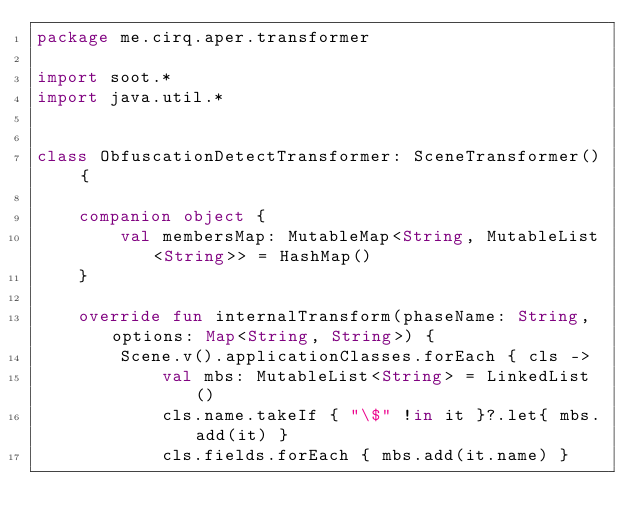Convert code to text. <code><loc_0><loc_0><loc_500><loc_500><_Kotlin_>package me.cirq.aper.transformer

import soot.*
import java.util.*


class ObfuscationDetectTransformer: SceneTransformer() {

    companion object {
        val membersMap: MutableMap<String, MutableList<String>> = HashMap()
    }

    override fun internalTransform(phaseName: String, options: Map<String, String>) {
        Scene.v().applicationClasses.forEach { cls ->
            val mbs: MutableList<String> = LinkedList()
            cls.name.takeIf { "\$" !in it }?.let{ mbs.add(it) }
            cls.fields.forEach { mbs.add(it.name) }</code> 